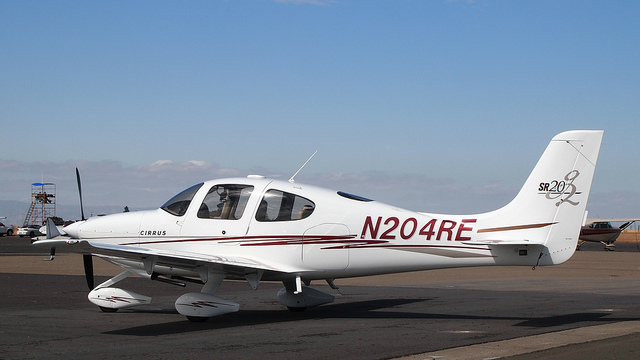<image>Is the plane occupied? It's uncertain if the plane is occupied. Is the plane occupied? I am not sure if the plane is occupied. It can be both occupied or not occupied. 